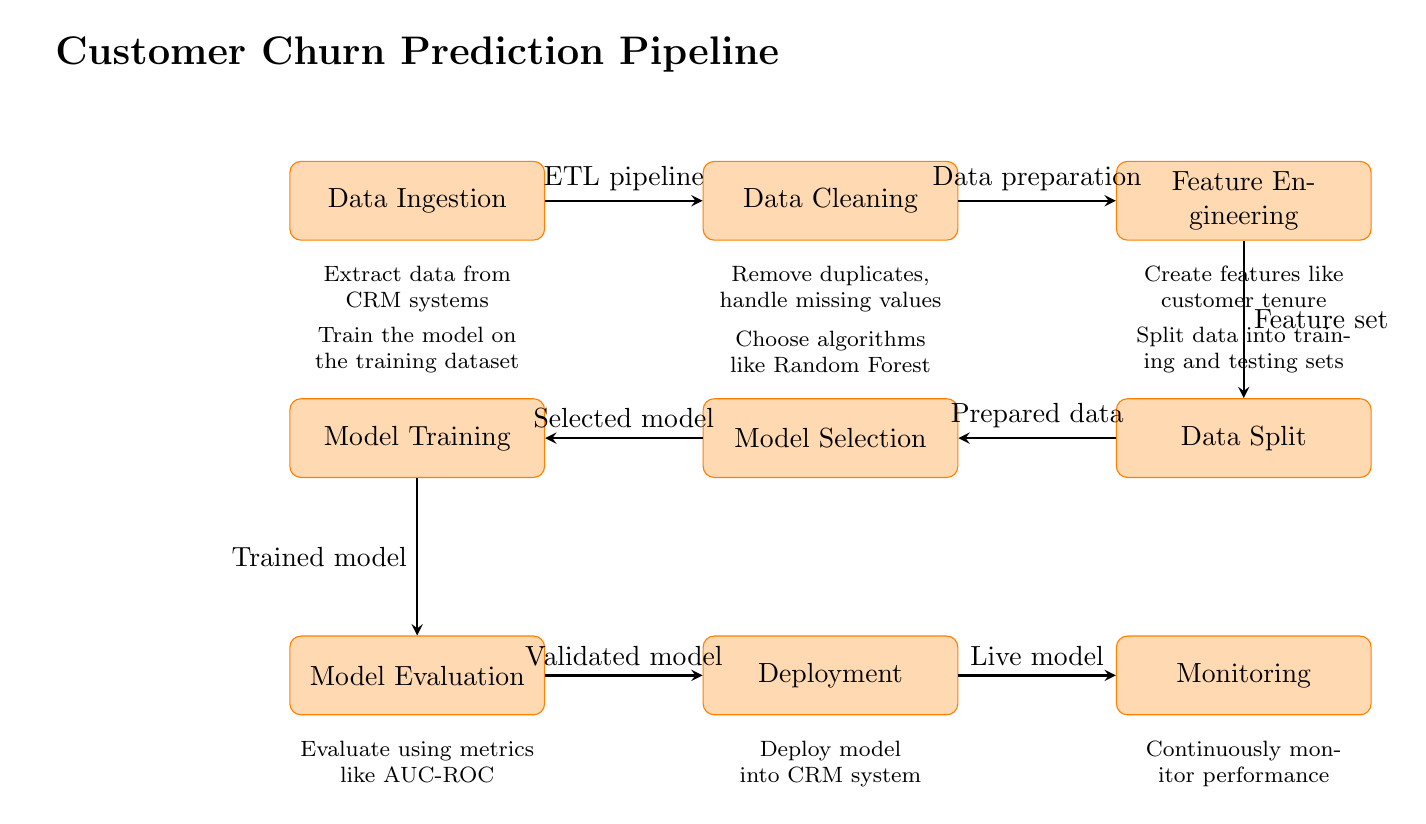What is the first step in the pipeline? The first step in the pipeline is "Data Ingestion," where data is extracted from CRM systems.
Answer: Data Ingestion What processes follow Data Cleaning? After Data Cleaning, the next process is Feature Engineering, where data preparation takes place.
Answer: Feature Engineering How many processes are in the pipeline? Counting all nodes in the pipeline, there are a total of 8 processes.
Answer: 8 What type of model is selected in the Model Selection phase? The diagram suggests selecting algorithms like Random Forest during the Model Selection phase.
Answer: Random Forest What is the last stage of the pipeline? The final stage of the pipeline is Monitoring, where the performance of the live model is continuously monitored.
Answer: Monitoring What is the purpose of Model Evaluation? Model Evaluation serves to evaluate the trained model using metrics like AUC-ROC.
Answer: AUC-ROC At which stage do we split the data into training and testing sets? The data split is performed in the Data Split stage of the pipeline.
Answer: Data Split How is the "live model" integrated after deployment? The live model is integrated into the CRM system after deployment.
Answer: CRM system What is the relationship between Feature Engineering and Data Split? Feature Engineering provides the feature set used in the subsequent Data Split process.
Answer: Feature set 